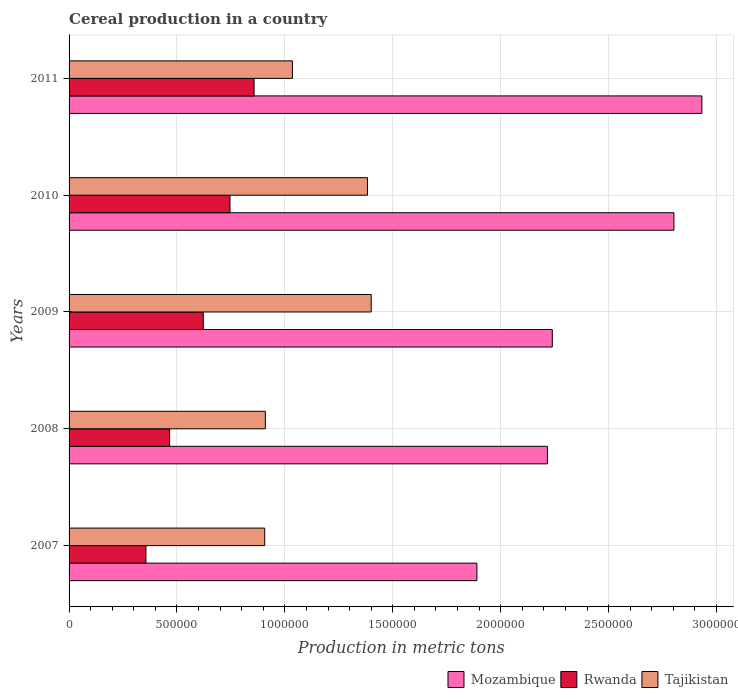How many different coloured bars are there?
Provide a short and direct response. 3. Are the number of bars per tick equal to the number of legend labels?
Give a very brief answer. Yes. Are the number of bars on each tick of the Y-axis equal?
Your answer should be compact. Yes. How many bars are there on the 3rd tick from the top?
Offer a very short reply. 3. What is the total cereal production in Mozambique in 2008?
Offer a terse response. 2.22e+06. Across all years, what is the maximum total cereal production in Rwanda?
Keep it short and to the point. 8.57e+05. Across all years, what is the minimum total cereal production in Tajikistan?
Offer a terse response. 9.07e+05. In which year was the total cereal production in Mozambique maximum?
Offer a very short reply. 2011. What is the total total cereal production in Mozambique in the graph?
Give a very brief answer. 1.21e+07. What is the difference between the total cereal production in Tajikistan in 2007 and that in 2009?
Your answer should be compact. -4.93e+05. What is the difference between the total cereal production in Mozambique in 2010 and the total cereal production in Rwanda in 2009?
Offer a terse response. 2.18e+06. What is the average total cereal production in Mozambique per year?
Give a very brief answer. 2.42e+06. In the year 2011, what is the difference between the total cereal production in Tajikistan and total cereal production in Rwanda?
Make the answer very short. 1.78e+05. In how many years, is the total cereal production in Rwanda greater than 2400000 metric tons?
Offer a terse response. 0. What is the ratio of the total cereal production in Mozambique in 2008 to that in 2010?
Provide a succinct answer. 0.79. What is the difference between the highest and the second highest total cereal production in Rwanda?
Your answer should be compact. 1.12e+05. What is the difference between the highest and the lowest total cereal production in Mozambique?
Provide a succinct answer. 1.04e+06. Is the sum of the total cereal production in Tajikistan in 2008 and 2010 greater than the maximum total cereal production in Mozambique across all years?
Offer a terse response. No. What does the 2nd bar from the top in 2011 represents?
Your answer should be compact. Rwanda. What does the 3rd bar from the bottom in 2007 represents?
Keep it short and to the point. Tajikistan. Is it the case that in every year, the sum of the total cereal production in Tajikistan and total cereal production in Rwanda is greater than the total cereal production in Mozambique?
Offer a very short reply. No. What is the difference between two consecutive major ticks on the X-axis?
Offer a terse response. 5.00e+05. Does the graph contain any zero values?
Make the answer very short. No. Where does the legend appear in the graph?
Offer a very short reply. Bottom right. How are the legend labels stacked?
Ensure brevity in your answer.  Horizontal. What is the title of the graph?
Offer a very short reply. Cereal production in a country. What is the label or title of the X-axis?
Offer a terse response. Production in metric tons. What is the label or title of the Y-axis?
Make the answer very short. Years. What is the Production in metric tons in Mozambique in 2007?
Provide a short and direct response. 1.89e+06. What is the Production in metric tons in Rwanda in 2007?
Your answer should be very brief. 3.56e+05. What is the Production in metric tons in Tajikistan in 2007?
Your response must be concise. 9.07e+05. What is the Production in metric tons in Mozambique in 2008?
Your answer should be compact. 2.22e+06. What is the Production in metric tons of Rwanda in 2008?
Your answer should be very brief. 4.66e+05. What is the Production in metric tons in Tajikistan in 2008?
Give a very brief answer. 9.10e+05. What is the Production in metric tons in Mozambique in 2009?
Provide a succinct answer. 2.24e+06. What is the Production in metric tons in Rwanda in 2009?
Your answer should be compact. 6.22e+05. What is the Production in metric tons of Tajikistan in 2009?
Give a very brief answer. 1.40e+06. What is the Production in metric tons of Mozambique in 2010?
Your response must be concise. 2.80e+06. What is the Production in metric tons in Rwanda in 2010?
Keep it short and to the point. 7.46e+05. What is the Production in metric tons in Tajikistan in 2010?
Your answer should be compact. 1.38e+06. What is the Production in metric tons in Mozambique in 2011?
Offer a terse response. 2.93e+06. What is the Production in metric tons of Rwanda in 2011?
Offer a terse response. 8.57e+05. What is the Production in metric tons in Tajikistan in 2011?
Offer a very short reply. 1.03e+06. Across all years, what is the maximum Production in metric tons of Mozambique?
Offer a very short reply. 2.93e+06. Across all years, what is the maximum Production in metric tons of Rwanda?
Keep it short and to the point. 8.57e+05. Across all years, what is the maximum Production in metric tons of Tajikistan?
Your response must be concise. 1.40e+06. Across all years, what is the minimum Production in metric tons of Mozambique?
Make the answer very short. 1.89e+06. Across all years, what is the minimum Production in metric tons in Rwanda?
Offer a terse response. 3.56e+05. Across all years, what is the minimum Production in metric tons in Tajikistan?
Your answer should be compact. 9.07e+05. What is the total Production in metric tons in Mozambique in the graph?
Give a very brief answer. 1.21e+07. What is the total Production in metric tons of Rwanda in the graph?
Your answer should be compact. 3.05e+06. What is the total Production in metric tons of Tajikistan in the graph?
Provide a short and direct response. 5.63e+06. What is the difference between the Production in metric tons in Mozambique in 2007 and that in 2008?
Offer a very short reply. -3.27e+05. What is the difference between the Production in metric tons in Rwanda in 2007 and that in 2008?
Offer a terse response. -1.10e+05. What is the difference between the Production in metric tons in Tajikistan in 2007 and that in 2008?
Your response must be concise. -2948. What is the difference between the Production in metric tons in Mozambique in 2007 and that in 2009?
Offer a terse response. -3.49e+05. What is the difference between the Production in metric tons of Rwanda in 2007 and that in 2009?
Provide a short and direct response. -2.66e+05. What is the difference between the Production in metric tons in Tajikistan in 2007 and that in 2009?
Ensure brevity in your answer.  -4.93e+05. What is the difference between the Production in metric tons of Mozambique in 2007 and that in 2010?
Provide a succinct answer. -9.13e+05. What is the difference between the Production in metric tons of Rwanda in 2007 and that in 2010?
Provide a short and direct response. -3.89e+05. What is the difference between the Production in metric tons in Tajikistan in 2007 and that in 2010?
Provide a short and direct response. -4.76e+05. What is the difference between the Production in metric tons of Mozambique in 2007 and that in 2011?
Provide a short and direct response. -1.04e+06. What is the difference between the Production in metric tons of Rwanda in 2007 and that in 2011?
Provide a succinct answer. -5.01e+05. What is the difference between the Production in metric tons in Tajikistan in 2007 and that in 2011?
Your answer should be very brief. -1.28e+05. What is the difference between the Production in metric tons in Mozambique in 2008 and that in 2009?
Keep it short and to the point. -2.26e+04. What is the difference between the Production in metric tons in Rwanda in 2008 and that in 2009?
Make the answer very short. -1.56e+05. What is the difference between the Production in metric tons in Tajikistan in 2008 and that in 2009?
Keep it short and to the point. -4.90e+05. What is the difference between the Production in metric tons in Mozambique in 2008 and that in 2010?
Offer a terse response. -5.86e+05. What is the difference between the Production in metric tons in Rwanda in 2008 and that in 2010?
Your answer should be compact. -2.80e+05. What is the difference between the Production in metric tons of Tajikistan in 2008 and that in 2010?
Offer a very short reply. -4.73e+05. What is the difference between the Production in metric tons in Mozambique in 2008 and that in 2011?
Provide a short and direct response. -7.16e+05. What is the difference between the Production in metric tons of Rwanda in 2008 and that in 2011?
Provide a short and direct response. -3.91e+05. What is the difference between the Production in metric tons of Tajikistan in 2008 and that in 2011?
Make the answer very short. -1.25e+05. What is the difference between the Production in metric tons in Mozambique in 2009 and that in 2010?
Offer a terse response. -5.64e+05. What is the difference between the Production in metric tons of Rwanda in 2009 and that in 2010?
Offer a terse response. -1.24e+05. What is the difference between the Production in metric tons of Tajikistan in 2009 and that in 2010?
Your answer should be very brief. 1.73e+04. What is the difference between the Production in metric tons of Mozambique in 2009 and that in 2011?
Your answer should be compact. -6.93e+05. What is the difference between the Production in metric tons in Rwanda in 2009 and that in 2011?
Your answer should be compact. -2.35e+05. What is the difference between the Production in metric tons in Tajikistan in 2009 and that in 2011?
Keep it short and to the point. 3.65e+05. What is the difference between the Production in metric tons in Mozambique in 2010 and that in 2011?
Your answer should be very brief. -1.29e+05. What is the difference between the Production in metric tons of Rwanda in 2010 and that in 2011?
Your answer should be compact. -1.12e+05. What is the difference between the Production in metric tons in Tajikistan in 2010 and that in 2011?
Offer a very short reply. 3.48e+05. What is the difference between the Production in metric tons of Mozambique in 2007 and the Production in metric tons of Rwanda in 2008?
Keep it short and to the point. 1.42e+06. What is the difference between the Production in metric tons of Mozambique in 2007 and the Production in metric tons of Tajikistan in 2008?
Keep it short and to the point. 9.80e+05. What is the difference between the Production in metric tons of Rwanda in 2007 and the Production in metric tons of Tajikistan in 2008?
Provide a succinct answer. -5.53e+05. What is the difference between the Production in metric tons in Mozambique in 2007 and the Production in metric tons in Rwanda in 2009?
Your answer should be very brief. 1.27e+06. What is the difference between the Production in metric tons in Mozambique in 2007 and the Production in metric tons in Tajikistan in 2009?
Your answer should be very brief. 4.90e+05. What is the difference between the Production in metric tons in Rwanda in 2007 and the Production in metric tons in Tajikistan in 2009?
Give a very brief answer. -1.04e+06. What is the difference between the Production in metric tons of Mozambique in 2007 and the Production in metric tons of Rwanda in 2010?
Ensure brevity in your answer.  1.14e+06. What is the difference between the Production in metric tons in Mozambique in 2007 and the Production in metric tons in Tajikistan in 2010?
Provide a short and direct response. 5.07e+05. What is the difference between the Production in metric tons of Rwanda in 2007 and the Production in metric tons of Tajikistan in 2010?
Provide a succinct answer. -1.03e+06. What is the difference between the Production in metric tons in Mozambique in 2007 and the Production in metric tons in Rwanda in 2011?
Offer a terse response. 1.03e+06. What is the difference between the Production in metric tons in Mozambique in 2007 and the Production in metric tons in Tajikistan in 2011?
Make the answer very short. 8.55e+05. What is the difference between the Production in metric tons of Rwanda in 2007 and the Production in metric tons of Tajikistan in 2011?
Ensure brevity in your answer.  -6.79e+05. What is the difference between the Production in metric tons in Mozambique in 2008 and the Production in metric tons in Rwanda in 2009?
Give a very brief answer. 1.59e+06. What is the difference between the Production in metric tons of Mozambique in 2008 and the Production in metric tons of Tajikistan in 2009?
Your answer should be very brief. 8.17e+05. What is the difference between the Production in metric tons in Rwanda in 2008 and the Production in metric tons in Tajikistan in 2009?
Keep it short and to the point. -9.34e+05. What is the difference between the Production in metric tons of Mozambique in 2008 and the Production in metric tons of Rwanda in 2010?
Keep it short and to the point. 1.47e+06. What is the difference between the Production in metric tons of Mozambique in 2008 and the Production in metric tons of Tajikistan in 2010?
Offer a terse response. 8.34e+05. What is the difference between the Production in metric tons of Rwanda in 2008 and the Production in metric tons of Tajikistan in 2010?
Keep it short and to the point. -9.17e+05. What is the difference between the Production in metric tons of Mozambique in 2008 and the Production in metric tons of Rwanda in 2011?
Provide a short and direct response. 1.36e+06. What is the difference between the Production in metric tons in Mozambique in 2008 and the Production in metric tons in Tajikistan in 2011?
Ensure brevity in your answer.  1.18e+06. What is the difference between the Production in metric tons in Rwanda in 2008 and the Production in metric tons in Tajikistan in 2011?
Your answer should be very brief. -5.69e+05. What is the difference between the Production in metric tons of Mozambique in 2009 and the Production in metric tons of Rwanda in 2010?
Provide a short and direct response. 1.49e+06. What is the difference between the Production in metric tons of Mozambique in 2009 and the Production in metric tons of Tajikistan in 2010?
Make the answer very short. 8.56e+05. What is the difference between the Production in metric tons of Rwanda in 2009 and the Production in metric tons of Tajikistan in 2010?
Your answer should be compact. -7.61e+05. What is the difference between the Production in metric tons in Mozambique in 2009 and the Production in metric tons in Rwanda in 2011?
Ensure brevity in your answer.  1.38e+06. What is the difference between the Production in metric tons of Mozambique in 2009 and the Production in metric tons of Tajikistan in 2011?
Ensure brevity in your answer.  1.20e+06. What is the difference between the Production in metric tons in Rwanda in 2009 and the Production in metric tons in Tajikistan in 2011?
Keep it short and to the point. -4.13e+05. What is the difference between the Production in metric tons in Mozambique in 2010 and the Production in metric tons in Rwanda in 2011?
Provide a short and direct response. 1.95e+06. What is the difference between the Production in metric tons of Mozambique in 2010 and the Production in metric tons of Tajikistan in 2011?
Offer a terse response. 1.77e+06. What is the difference between the Production in metric tons of Rwanda in 2010 and the Production in metric tons of Tajikistan in 2011?
Offer a very short reply. -2.89e+05. What is the average Production in metric tons of Mozambique per year?
Provide a short and direct response. 2.42e+06. What is the average Production in metric tons of Rwanda per year?
Provide a succinct answer. 6.09e+05. What is the average Production in metric tons of Tajikistan per year?
Offer a terse response. 1.13e+06. In the year 2007, what is the difference between the Production in metric tons of Mozambique and Production in metric tons of Rwanda?
Provide a short and direct response. 1.53e+06. In the year 2007, what is the difference between the Production in metric tons of Mozambique and Production in metric tons of Tajikistan?
Your answer should be compact. 9.83e+05. In the year 2007, what is the difference between the Production in metric tons in Rwanda and Production in metric tons in Tajikistan?
Your answer should be very brief. -5.50e+05. In the year 2008, what is the difference between the Production in metric tons of Mozambique and Production in metric tons of Rwanda?
Offer a terse response. 1.75e+06. In the year 2008, what is the difference between the Production in metric tons in Mozambique and Production in metric tons in Tajikistan?
Provide a short and direct response. 1.31e+06. In the year 2008, what is the difference between the Production in metric tons of Rwanda and Production in metric tons of Tajikistan?
Provide a succinct answer. -4.44e+05. In the year 2009, what is the difference between the Production in metric tons of Mozambique and Production in metric tons of Rwanda?
Your answer should be compact. 1.62e+06. In the year 2009, what is the difference between the Production in metric tons in Mozambique and Production in metric tons in Tajikistan?
Provide a succinct answer. 8.39e+05. In the year 2009, what is the difference between the Production in metric tons of Rwanda and Production in metric tons of Tajikistan?
Make the answer very short. -7.78e+05. In the year 2010, what is the difference between the Production in metric tons in Mozambique and Production in metric tons in Rwanda?
Ensure brevity in your answer.  2.06e+06. In the year 2010, what is the difference between the Production in metric tons in Mozambique and Production in metric tons in Tajikistan?
Give a very brief answer. 1.42e+06. In the year 2010, what is the difference between the Production in metric tons of Rwanda and Production in metric tons of Tajikistan?
Offer a very short reply. -6.37e+05. In the year 2011, what is the difference between the Production in metric tons in Mozambique and Production in metric tons in Rwanda?
Provide a succinct answer. 2.07e+06. In the year 2011, what is the difference between the Production in metric tons in Mozambique and Production in metric tons in Tajikistan?
Give a very brief answer. 1.90e+06. In the year 2011, what is the difference between the Production in metric tons in Rwanda and Production in metric tons in Tajikistan?
Make the answer very short. -1.78e+05. What is the ratio of the Production in metric tons of Mozambique in 2007 to that in 2008?
Offer a very short reply. 0.85. What is the ratio of the Production in metric tons in Rwanda in 2007 to that in 2008?
Provide a short and direct response. 0.76. What is the ratio of the Production in metric tons in Mozambique in 2007 to that in 2009?
Keep it short and to the point. 0.84. What is the ratio of the Production in metric tons of Rwanda in 2007 to that in 2009?
Your answer should be very brief. 0.57. What is the ratio of the Production in metric tons of Tajikistan in 2007 to that in 2009?
Give a very brief answer. 0.65. What is the ratio of the Production in metric tons of Mozambique in 2007 to that in 2010?
Keep it short and to the point. 0.67. What is the ratio of the Production in metric tons of Rwanda in 2007 to that in 2010?
Your answer should be very brief. 0.48. What is the ratio of the Production in metric tons of Tajikistan in 2007 to that in 2010?
Make the answer very short. 0.66. What is the ratio of the Production in metric tons in Mozambique in 2007 to that in 2011?
Your answer should be compact. 0.64. What is the ratio of the Production in metric tons in Rwanda in 2007 to that in 2011?
Provide a succinct answer. 0.42. What is the ratio of the Production in metric tons of Tajikistan in 2007 to that in 2011?
Give a very brief answer. 0.88. What is the ratio of the Production in metric tons in Rwanda in 2008 to that in 2009?
Keep it short and to the point. 0.75. What is the ratio of the Production in metric tons of Tajikistan in 2008 to that in 2009?
Offer a very short reply. 0.65. What is the ratio of the Production in metric tons of Mozambique in 2008 to that in 2010?
Your answer should be very brief. 0.79. What is the ratio of the Production in metric tons in Rwanda in 2008 to that in 2010?
Provide a short and direct response. 0.62. What is the ratio of the Production in metric tons of Tajikistan in 2008 to that in 2010?
Offer a terse response. 0.66. What is the ratio of the Production in metric tons of Mozambique in 2008 to that in 2011?
Make the answer very short. 0.76. What is the ratio of the Production in metric tons of Rwanda in 2008 to that in 2011?
Offer a very short reply. 0.54. What is the ratio of the Production in metric tons of Tajikistan in 2008 to that in 2011?
Provide a short and direct response. 0.88. What is the ratio of the Production in metric tons of Mozambique in 2009 to that in 2010?
Provide a short and direct response. 0.8. What is the ratio of the Production in metric tons in Rwanda in 2009 to that in 2010?
Your answer should be very brief. 0.83. What is the ratio of the Production in metric tons in Tajikistan in 2009 to that in 2010?
Offer a terse response. 1.01. What is the ratio of the Production in metric tons in Mozambique in 2009 to that in 2011?
Make the answer very short. 0.76. What is the ratio of the Production in metric tons in Rwanda in 2009 to that in 2011?
Your answer should be compact. 0.73. What is the ratio of the Production in metric tons of Tajikistan in 2009 to that in 2011?
Keep it short and to the point. 1.35. What is the ratio of the Production in metric tons of Mozambique in 2010 to that in 2011?
Give a very brief answer. 0.96. What is the ratio of the Production in metric tons of Rwanda in 2010 to that in 2011?
Provide a short and direct response. 0.87. What is the ratio of the Production in metric tons of Tajikistan in 2010 to that in 2011?
Keep it short and to the point. 1.34. What is the difference between the highest and the second highest Production in metric tons of Mozambique?
Keep it short and to the point. 1.29e+05. What is the difference between the highest and the second highest Production in metric tons of Rwanda?
Your answer should be compact. 1.12e+05. What is the difference between the highest and the second highest Production in metric tons in Tajikistan?
Make the answer very short. 1.73e+04. What is the difference between the highest and the lowest Production in metric tons in Mozambique?
Offer a very short reply. 1.04e+06. What is the difference between the highest and the lowest Production in metric tons in Rwanda?
Your response must be concise. 5.01e+05. What is the difference between the highest and the lowest Production in metric tons in Tajikistan?
Offer a terse response. 4.93e+05. 